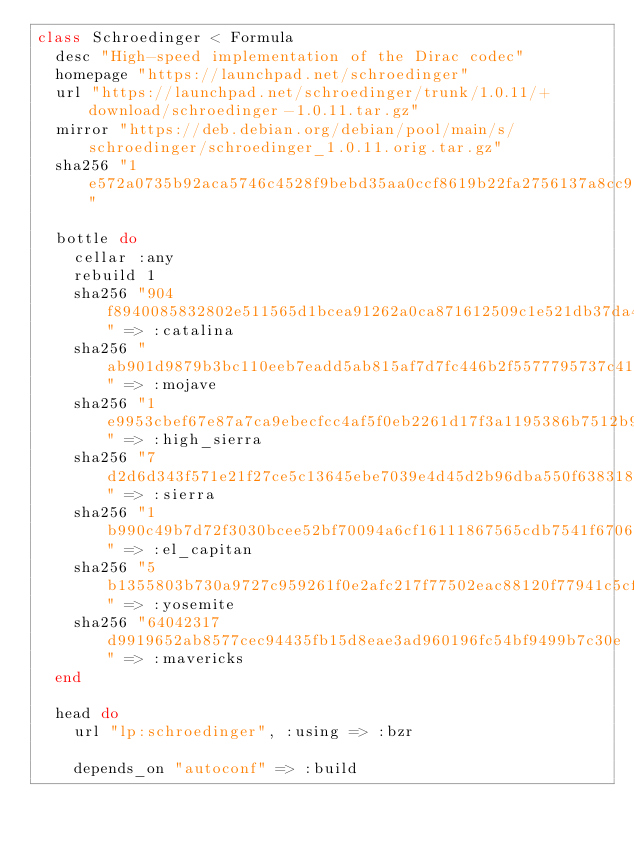<code> <loc_0><loc_0><loc_500><loc_500><_Ruby_>class Schroedinger < Formula
  desc "High-speed implementation of the Dirac codec"
  homepage "https://launchpad.net/schroedinger"
  url "https://launchpad.net/schroedinger/trunk/1.0.11/+download/schroedinger-1.0.11.tar.gz"
  mirror "https://deb.debian.org/debian/pool/main/s/schroedinger/schroedinger_1.0.11.orig.tar.gz"
  sha256 "1e572a0735b92aca5746c4528f9bebd35aa0ccf8619b22fa2756137a8cc9f912"

  bottle do
    cellar :any
    rebuild 1
    sha256 "904f8940085832802e511565d1bcea91262a0ca871612509c1e521db37da4227" => :catalina
    sha256 "ab901d9879b3bc110eeb7eadd5ab815af7d7fc446b2f5577795737c410c3bf4e" => :mojave
    sha256 "1e9953cbef67e87a7ca9ebecfcc4af5f0eb2261d17f3a1195386b7512b9312be" => :high_sierra
    sha256 "7d2d6d343f571e21f27ce5c13645ebe7039e4d45d2b96dba550f6383185c18f6" => :sierra
    sha256 "1b990c49b7d72f3030bcee52bf70094a6cf16111867565cdb7541f670636cf05" => :el_capitan
    sha256 "5b1355803b730a9727c959261f0e2afc217f77502eac88120f77941c5cf373db" => :yosemite
    sha256 "64042317d9919652ab8577cec94435fb15d8eae3ad960196fc54bf9499b7c30e" => :mavericks
  end

  head do
    url "lp:schroedinger", :using => :bzr

    depends_on "autoconf" => :build</code> 